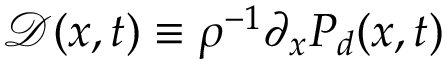<formula> <loc_0><loc_0><loc_500><loc_500>\mathcal { D } ( x , t ) \equiv \rho ^ { - 1 } \partial _ { x } P _ { d } ( x , t )</formula> 